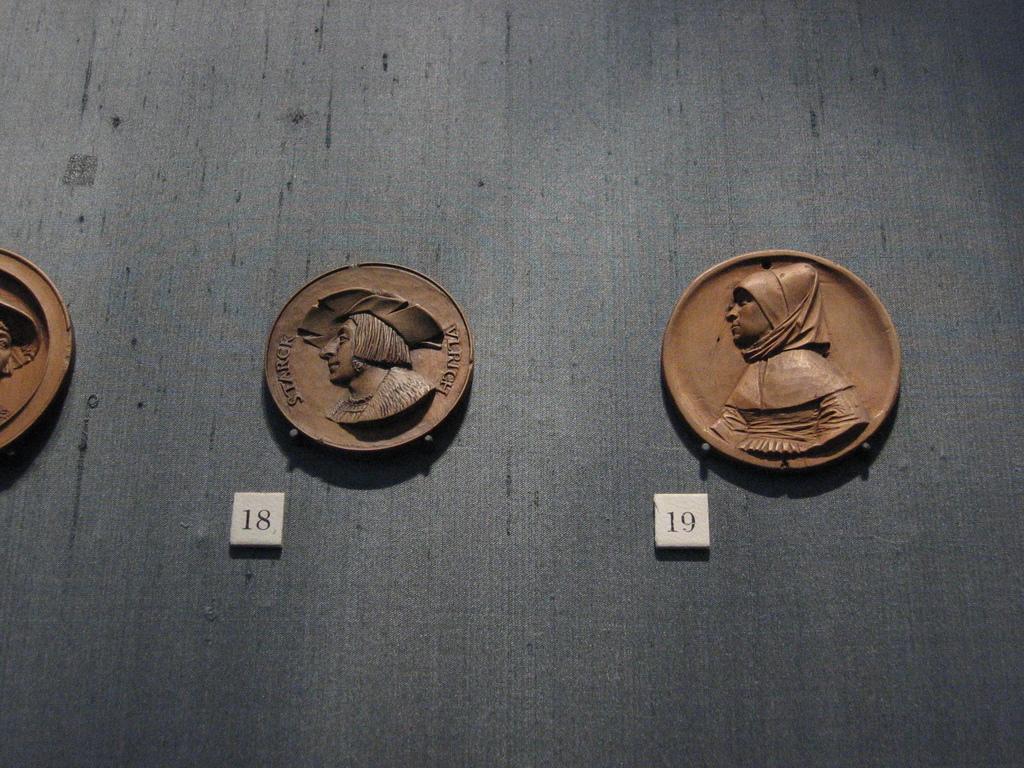What is the first coin number?
Your response must be concise. 18. What is the second coin number?
Provide a succinct answer. 19. 